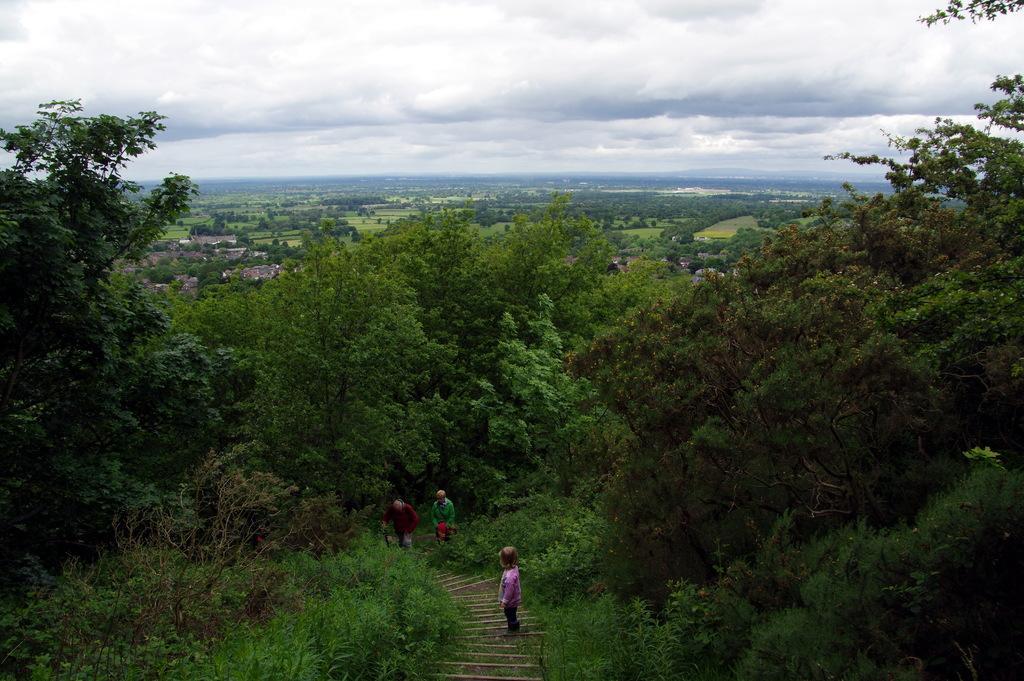In one or two sentences, can you explain what this image depicts? This image is taken outdoors. At the of the image there is a sky with clouds. At the bottom of the image there are a few plants and trees and there are a few stairs. There are three people on the stairs. In the middle of the image there are many trees and plants. 